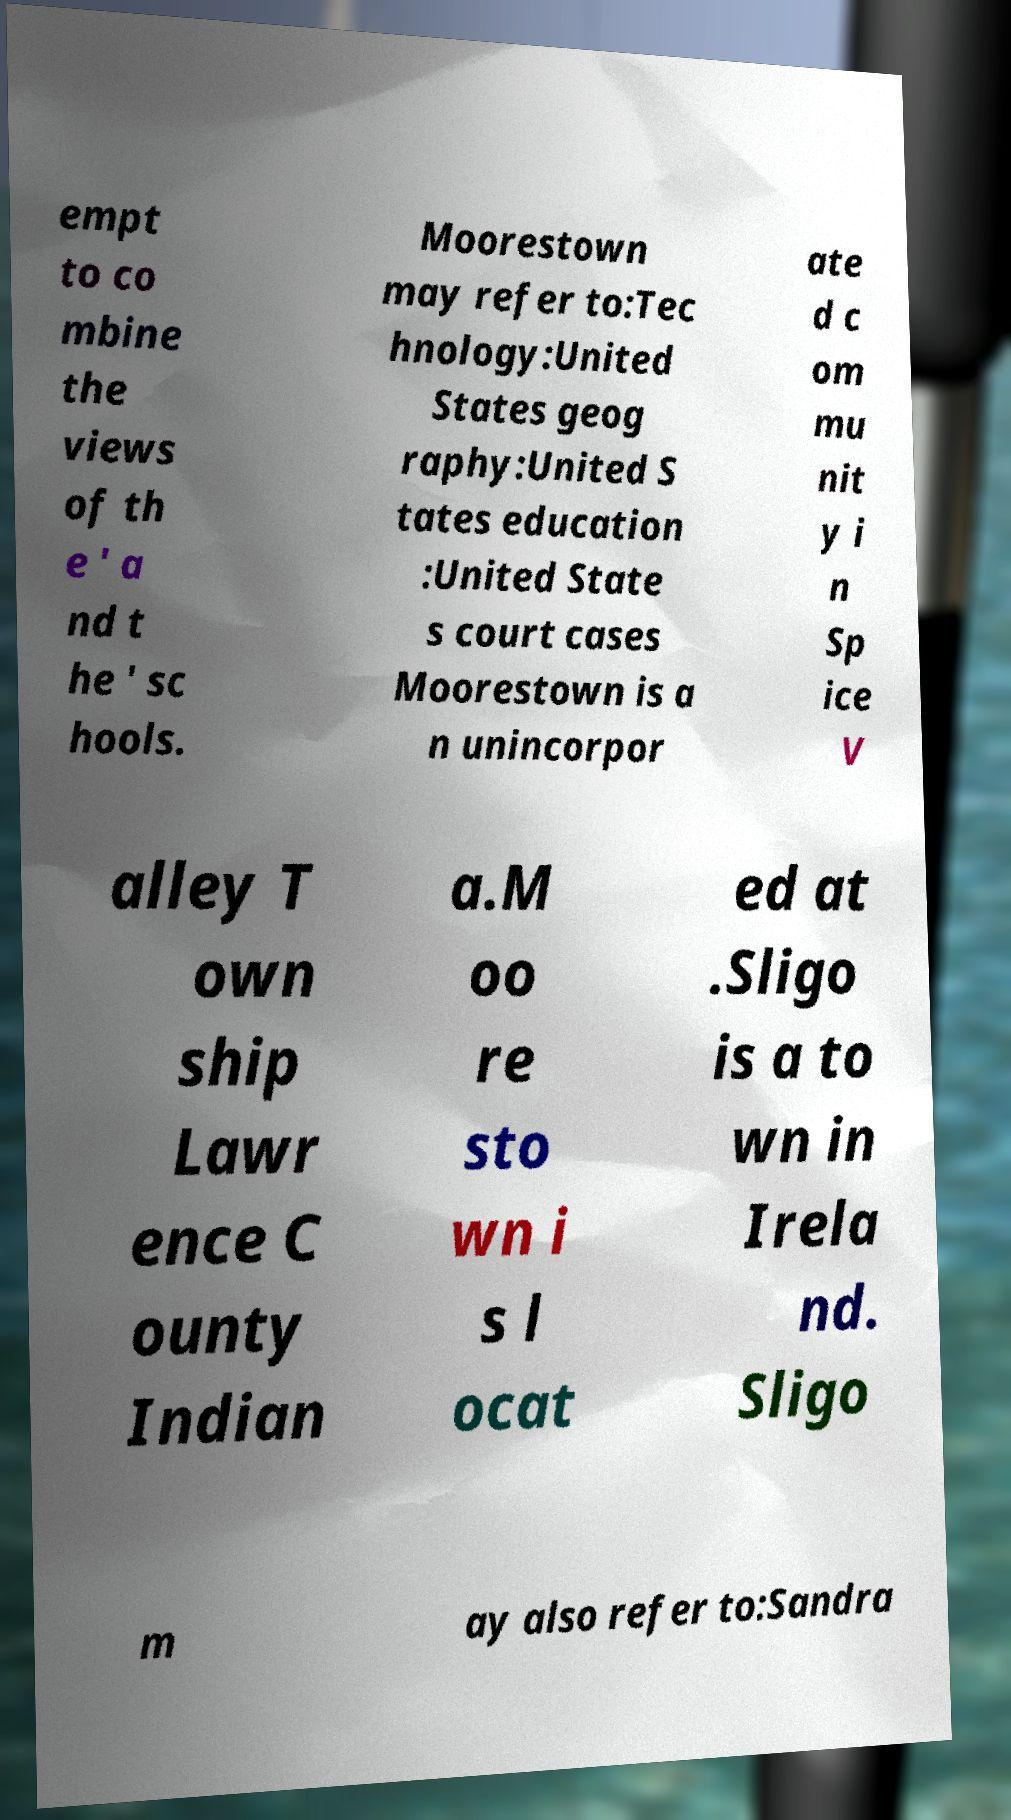What messages or text are displayed in this image? I need them in a readable, typed format. empt to co mbine the views of th e ' a nd t he ' sc hools. Moorestown may refer to:Tec hnology:United States geog raphy:United S tates education :United State s court cases Moorestown is a n unincorpor ate d c om mu nit y i n Sp ice V alley T own ship Lawr ence C ounty Indian a.M oo re sto wn i s l ocat ed at .Sligo is a to wn in Irela nd. Sligo m ay also refer to:Sandra 